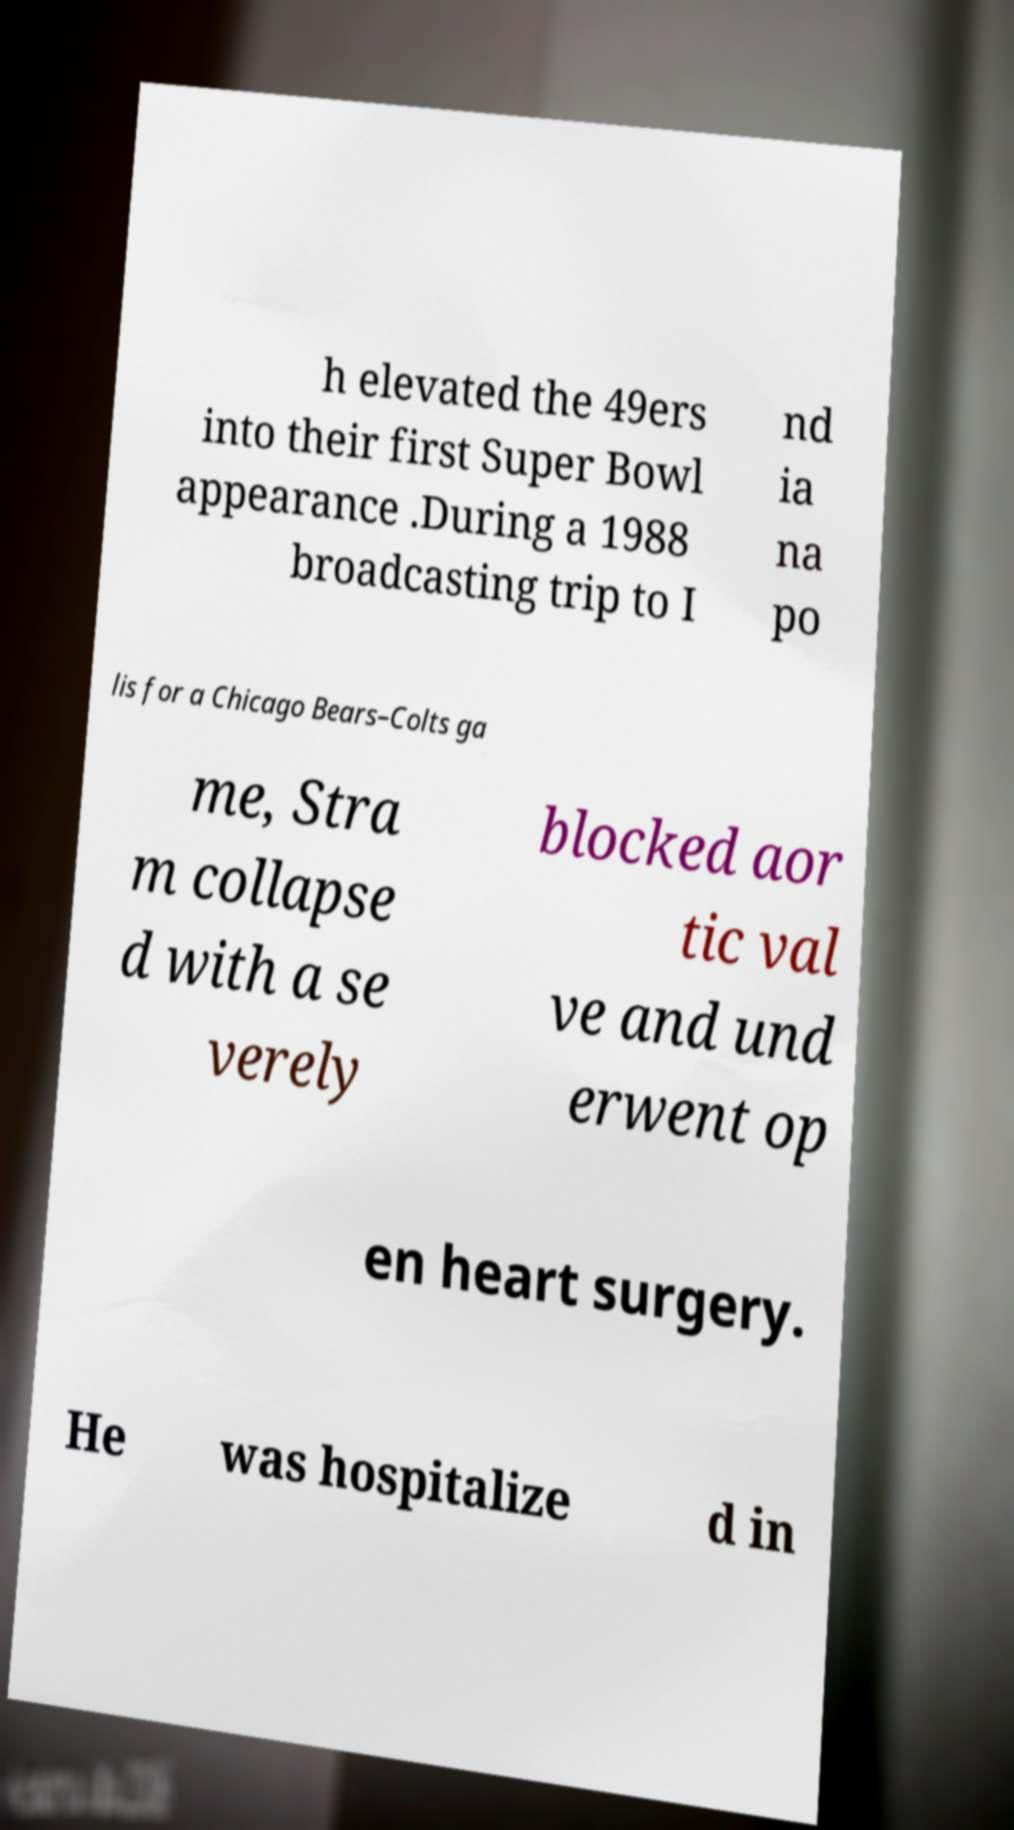For documentation purposes, I need the text within this image transcribed. Could you provide that? h elevated the 49ers into their first Super Bowl appearance .During a 1988 broadcasting trip to I nd ia na po lis for a Chicago Bears–Colts ga me, Stra m collapse d with a se verely blocked aor tic val ve and und erwent op en heart surgery. He was hospitalize d in 